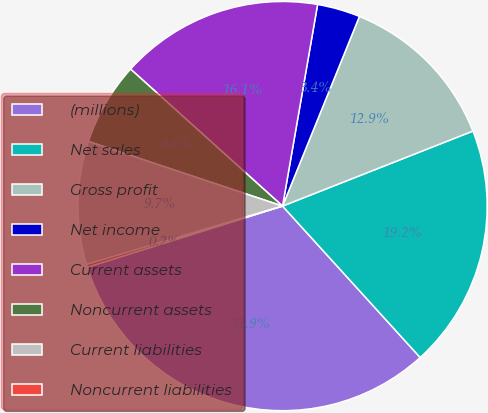<chart> <loc_0><loc_0><loc_500><loc_500><pie_chart><fcel>(millions)<fcel>Net sales<fcel>Gross profit<fcel>Net income<fcel>Current assets<fcel>Noncurrent assets<fcel>Current liabilities<fcel>Noncurrent liabilities<nl><fcel>31.92%<fcel>19.24%<fcel>12.9%<fcel>3.39%<fcel>16.07%<fcel>6.56%<fcel>9.73%<fcel>0.22%<nl></chart> 